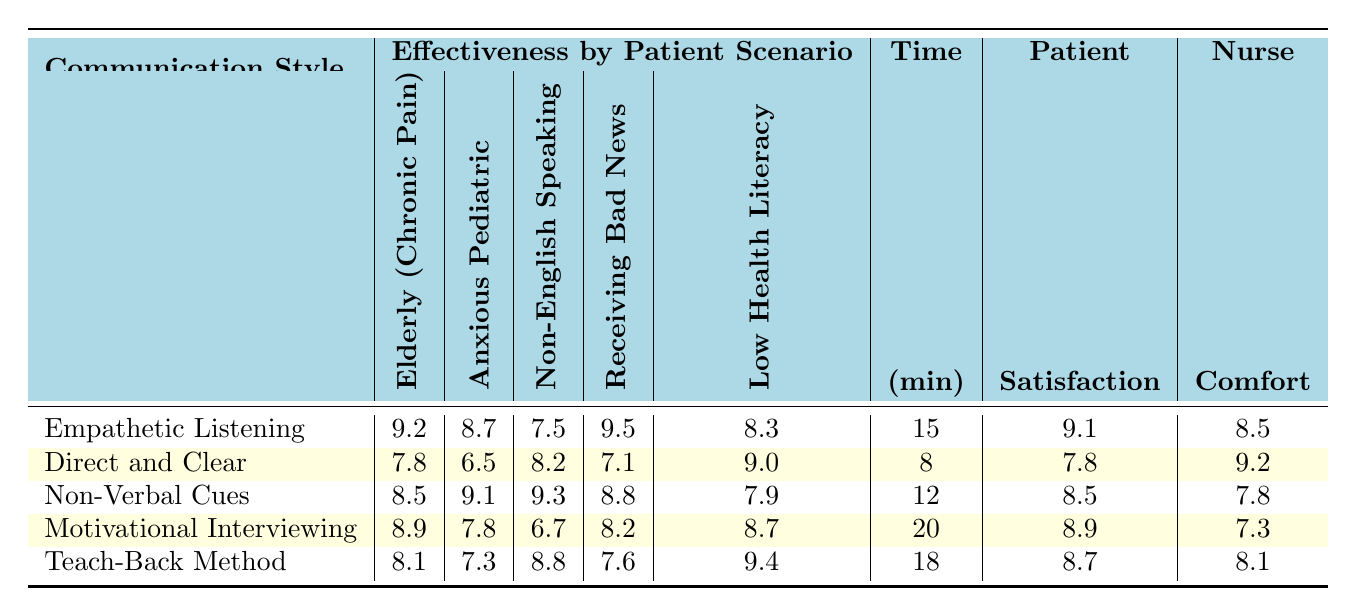What is the effectiveness rating for Empathetic Listening with an Anxious Pediatric Patient? The table shows that the effectiveness rating for Empathetic Listening with an Anxious Pediatric Patient is 8.7.
Answer: 8.7 Which communication style has the highest effectiveness rating when delivering bad news to a patient? By examining the ratings for "Patient Receiving Bad News," Empathetic Listening has the highest effectiveness rating at 9.5.
Answer: Empathetic Listening What is the average effectiveness rating of Direct and Clear communication across all patient scenarios? The effectiveness ratings for Direct and Clear are: 7.8 (Chronic Pain), 6.5 (Anxious Pediatric), 8.2 (Non-English Speaking), 7.1 (Receiving Bad News), and 9.0 (Low Health Literacy). Summing these gives 38.6, which divided by 5 (the number of scenarios) gives an average of 7.72.
Answer: 7.72 Is Non-Verbal Cues more effective than the Teach-Back Method for patients with Low Health Literacy? The effectiveness rating for Non-Verbal Cues with Low Health Literacy is 7.9, while for the Teach-Back Method it is 9.4. Since 7.9 is less than 9.4, Non-Verbal Cues is not more effective.
Answer: No Which communication style requires the most time on average? The average time in minutes for each communication style is compared: 15 for Empathetic Listening, 8 for Direct and Clear, 12 for Non-Verbal Cues, 20 for Motivational Interviewing, and 18 for Teach-Back Method. The highest is 20 minutes for Motivational Interviewing.
Answer: Motivational Interviewing What is the average patient satisfaction score for communication styles involving empathetic approaches? The satisfaction scores for empathetic strategies are: Empathetic Listening (9.1) and Motivational Interviewing (8.9). Their total is 18.0, and dividing by 2 yields an average score of 9.0.
Answer: 9.0 Which communication style has the lowest nurse comfort score? The nurse comfort scores are: 8.5 for Empathetic Listening, 9.2 for Direct and Clear, 7.8 for Non-Verbal Cues, 7.3 for Motivational Interviewing, and 8.1 for Teach-Back Method. The lowest score is 7.3 for Motivational Interviewing.
Answer: Motivational Interviewing Is the Teach-Back Method more effective than Non-Verbal Cues for Non-English Speaking patients? The effectiveness for Non-English Speaking patients is 8.8 for Teach-Back Method and 9.3 for Non-Verbal Cues. Since 8.8 is less than 9.3, Teach-Back is not more effective.
Answer: No What is the difference in satisfaction score between the most effective and least effective communication styles? The highest satisfaction score is 9.1 for Empathetic Listening, and the lowest is 7.3 for Motivational Interviewing. The difference is 9.1 - 7.3 = 1.8.
Answer: 1.8 